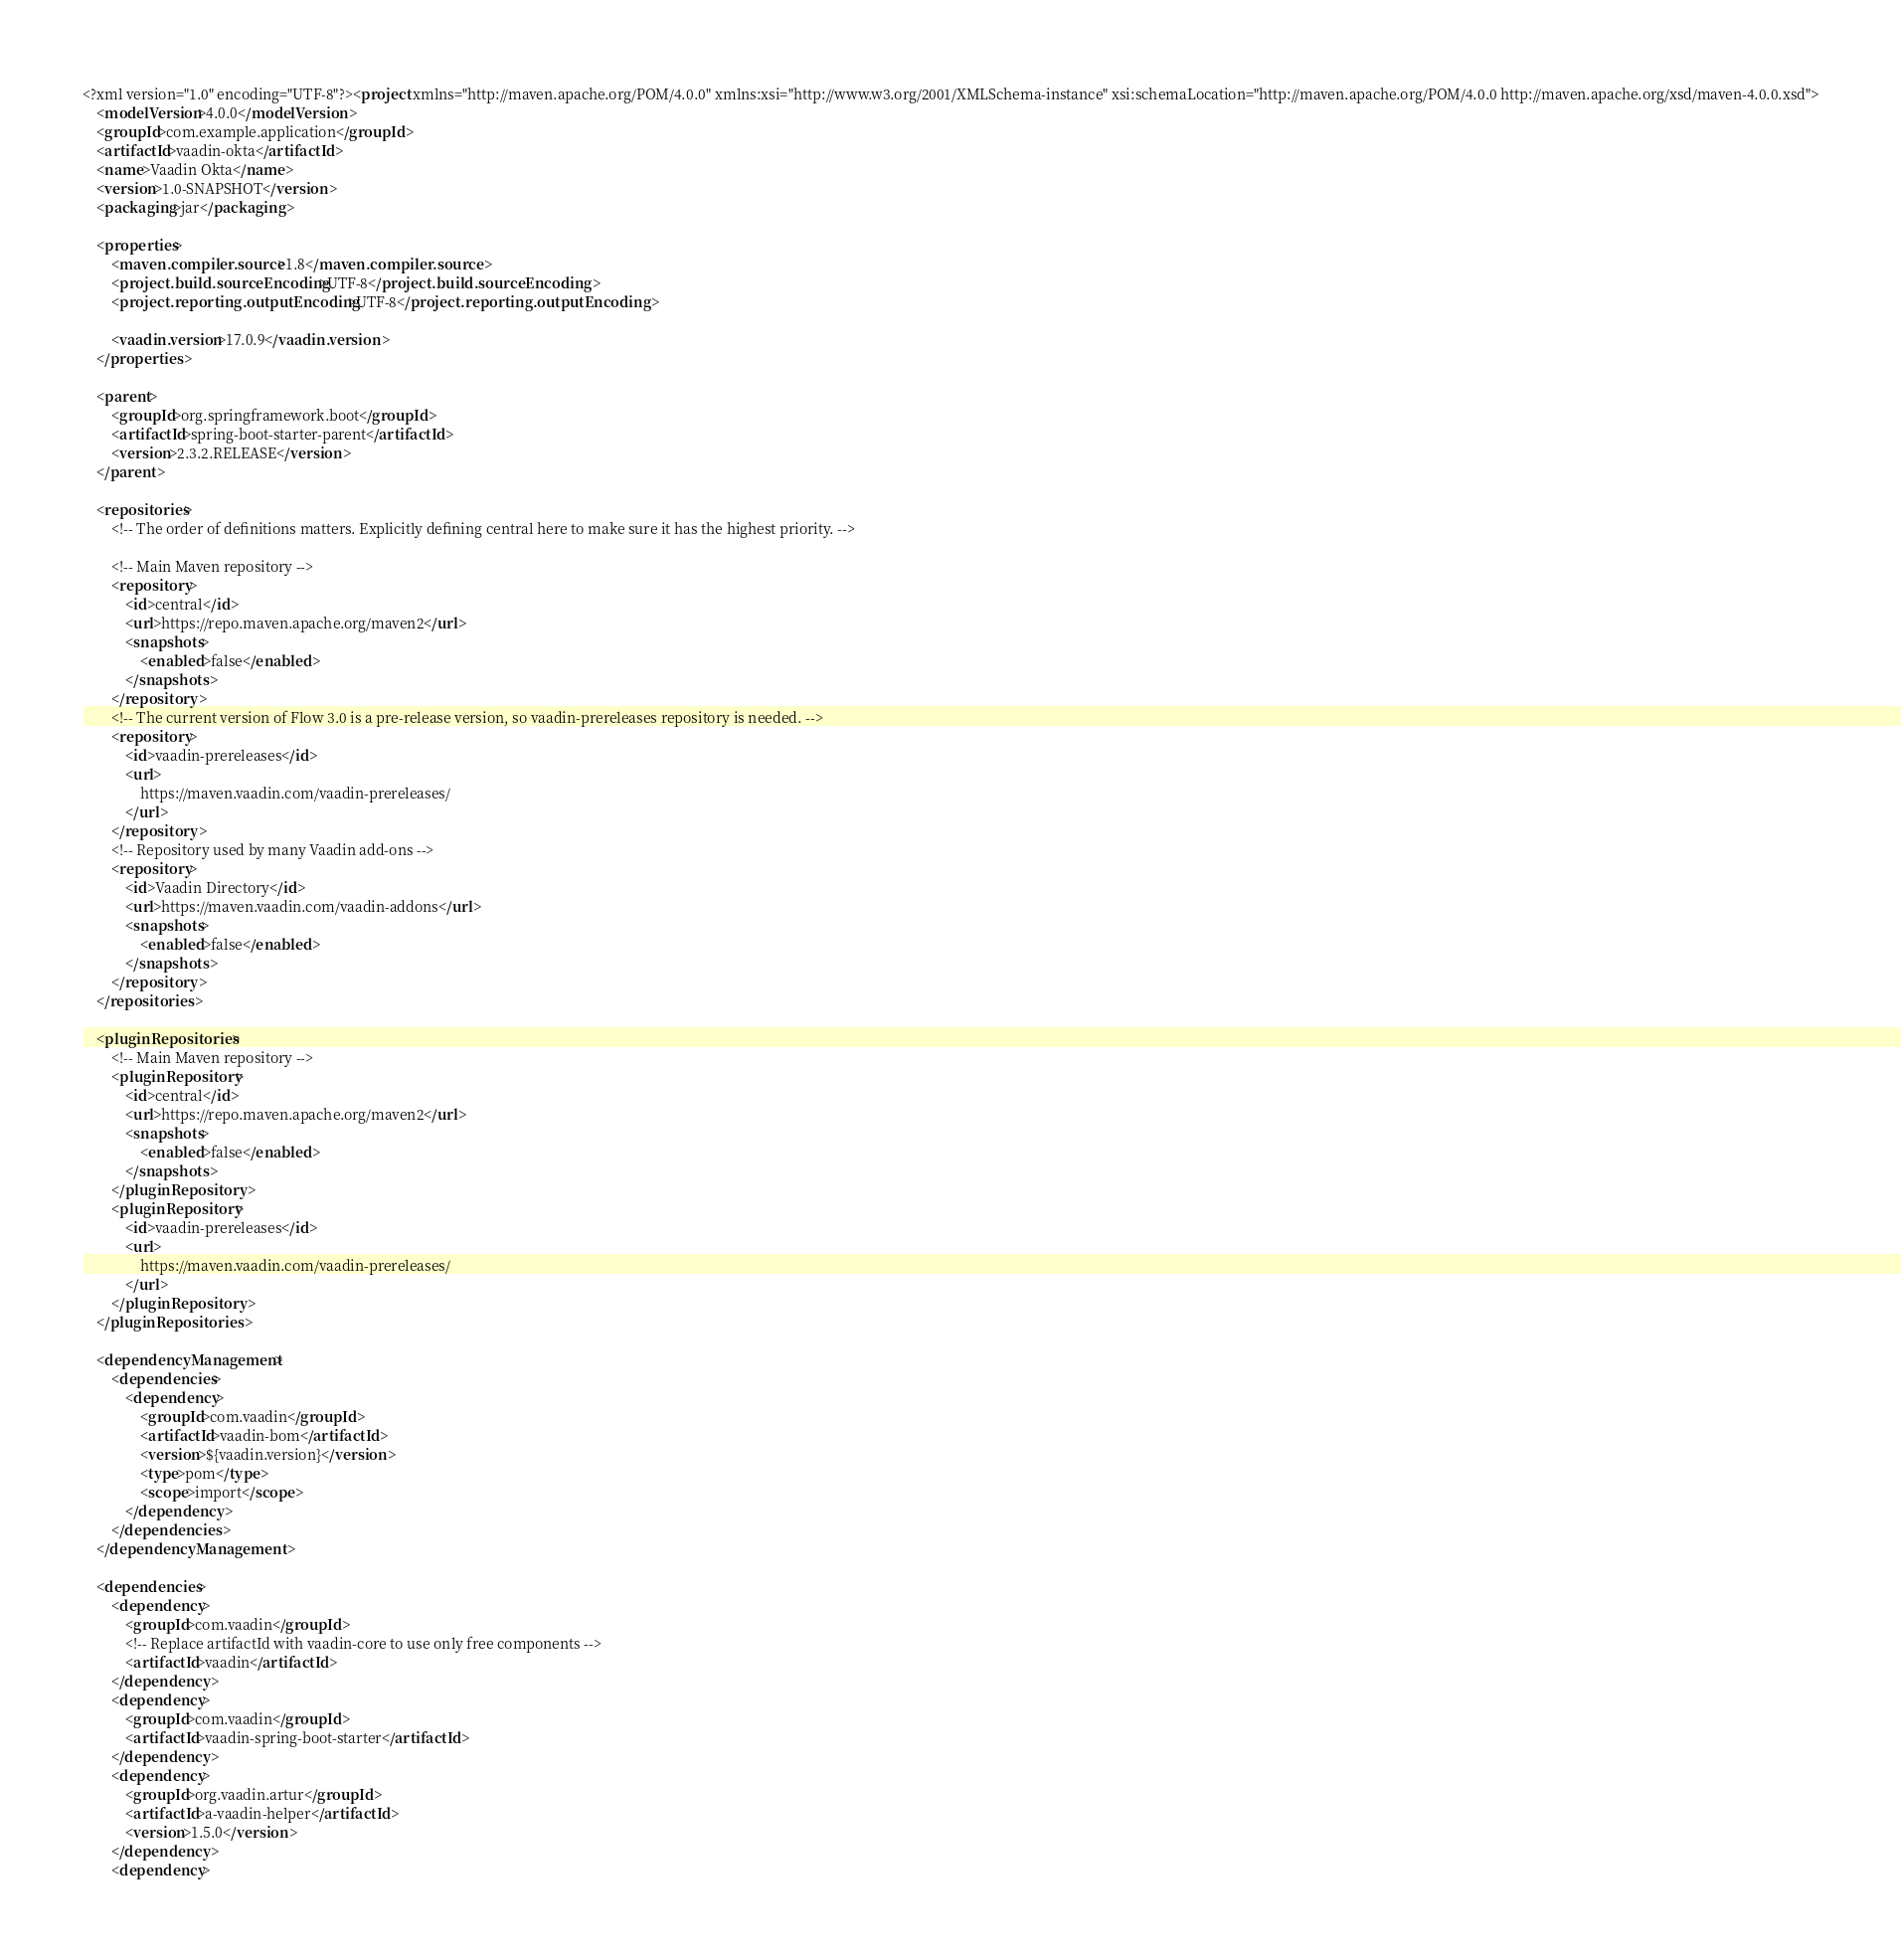Convert code to text. <code><loc_0><loc_0><loc_500><loc_500><_XML_><?xml version="1.0" encoding="UTF-8"?><project xmlns="http://maven.apache.org/POM/4.0.0" xmlns:xsi="http://www.w3.org/2001/XMLSchema-instance" xsi:schemaLocation="http://maven.apache.org/POM/4.0.0 http://maven.apache.org/xsd/maven-4.0.0.xsd">
    <modelVersion>4.0.0</modelVersion>
    <groupId>com.example.application</groupId>
    <artifactId>vaadin-okta</artifactId>
    <name>Vaadin Okta</name>
    <version>1.0-SNAPSHOT</version>
    <packaging>jar</packaging>

    <properties>
        <maven.compiler.source>1.8</maven.compiler.source>
        <project.build.sourceEncoding>UTF-8</project.build.sourceEncoding>
        <project.reporting.outputEncoding>UTF-8</project.reporting.outputEncoding>

        <vaadin.version>17.0.9</vaadin.version>
    </properties>

    <parent>
        <groupId>org.springframework.boot</groupId>
        <artifactId>spring-boot-starter-parent</artifactId>
        <version>2.3.2.RELEASE</version>
    </parent>

    <repositories>
        <!-- The order of definitions matters. Explicitly defining central here to make sure it has the highest priority. -->

        <!-- Main Maven repository -->
        <repository>
            <id>central</id>
            <url>https://repo.maven.apache.org/maven2</url>
            <snapshots>
                <enabled>false</enabled>
            </snapshots>
        </repository>
        <!-- The current version of Flow 3.0 is a pre-release version, so vaadin-prereleases repository is needed. -->
        <repository>
            <id>vaadin-prereleases</id>
            <url>
                https://maven.vaadin.com/vaadin-prereleases/
            </url>
        </repository>
        <!-- Repository used by many Vaadin add-ons -->
        <repository>
            <id>Vaadin Directory</id>
            <url>https://maven.vaadin.com/vaadin-addons</url>
            <snapshots>
                <enabled>false</enabled>
            </snapshots>
        </repository>
    </repositories>

    <pluginRepositories>
        <!-- Main Maven repository -->
        <pluginRepository>
            <id>central</id>
            <url>https://repo.maven.apache.org/maven2</url>
            <snapshots>
                <enabled>false</enabled>
            </snapshots>
        </pluginRepository>
        <pluginRepository>
            <id>vaadin-prereleases</id>
            <url>
                https://maven.vaadin.com/vaadin-prereleases/
            </url>
        </pluginRepository>
    </pluginRepositories>

    <dependencyManagement>
        <dependencies>
            <dependency>
                <groupId>com.vaadin</groupId>
                <artifactId>vaadin-bom</artifactId>
                <version>${vaadin.version}</version>
                <type>pom</type>
                <scope>import</scope>
            </dependency>
        </dependencies>
    </dependencyManagement>

    <dependencies>
        <dependency>
            <groupId>com.vaadin</groupId>
            <!-- Replace artifactId with vaadin-core to use only free components -->
            <artifactId>vaadin</artifactId>
        </dependency>
        <dependency>
            <groupId>com.vaadin</groupId>
            <artifactId>vaadin-spring-boot-starter</artifactId>
        </dependency>
        <dependency>
            <groupId>org.vaadin.artur</groupId>
            <artifactId>a-vaadin-helper</artifactId>
            <version>1.5.0</version>
        </dependency>
        <dependency></code> 